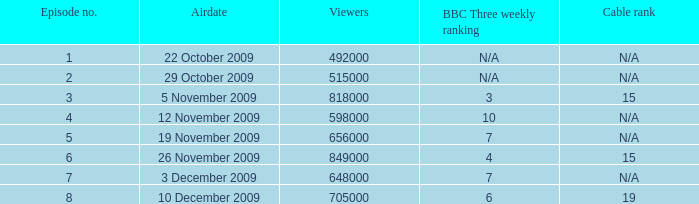Help me parse the entirety of this table. {'header': ['Episode no.', 'Airdate', 'Viewers', 'BBC Three weekly ranking', 'Cable rank'], 'rows': [['1', '22 October 2009', '492000', 'N/A', 'N/A'], ['2', '29 October 2009', '515000', 'N/A', 'N/A'], ['3', '5 November 2009', '818000', '3', '15'], ['4', '12 November 2009', '598000', '10', 'N/A'], ['5', '19 November 2009', '656000', '7', 'N/A'], ['6', '26 November 2009', '849000', '4', '15'], ['7', '3 December 2009', '648000', '7', 'N/A'], ['8', '10 December 2009', '705000', '6', '19']]} How many entries are shown for viewers when the airdate was 26 november 2009? 1.0. 